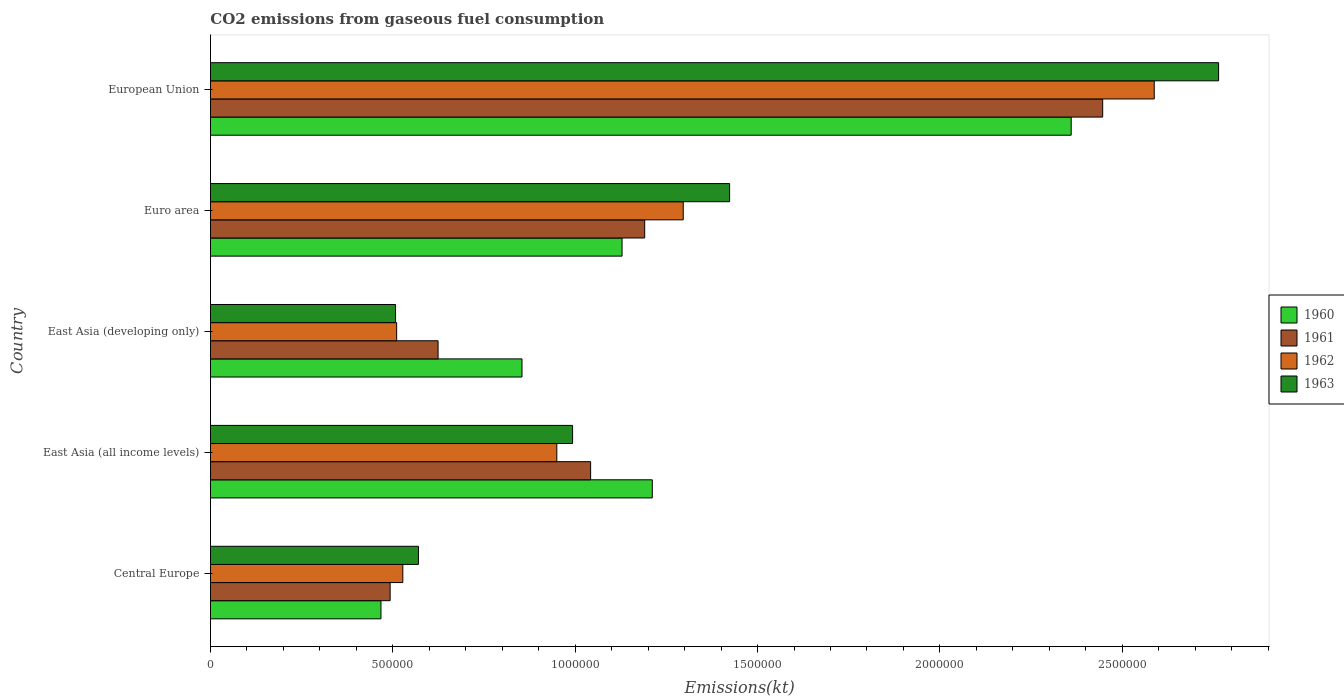Are the number of bars on each tick of the Y-axis equal?
Offer a very short reply. Yes. How many bars are there on the 1st tick from the top?
Offer a very short reply. 4. What is the label of the 1st group of bars from the top?
Offer a very short reply. European Union. What is the amount of CO2 emitted in 1961 in East Asia (developing only)?
Your answer should be very brief. 6.24e+05. Across all countries, what is the maximum amount of CO2 emitted in 1961?
Give a very brief answer. 2.45e+06. Across all countries, what is the minimum amount of CO2 emitted in 1961?
Your response must be concise. 4.93e+05. In which country was the amount of CO2 emitted in 1960 maximum?
Your response must be concise. European Union. In which country was the amount of CO2 emitted in 1961 minimum?
Provide a short and direct response. Central Europe. What is the total amount of CO2 emitted in 1960 in the graph?
Make the answer very short. 6.02e+06. What is the difference between the amount of CO2 emitted in 1960 in East Asia (developing only) and that in Euro area?
Provide a short and direct response. -2.74e+05. What is the difference between the amount of CO2 emitted in 1962 in Central Europe and the amount of CO2 emitted in 1963 in European Union?
Provide a short and direct response. -2.24e+06. What is the average amount of CO2 emitted in 1961 per country?
Offer a terse response. 1.16e+06. What is the difference between the amount of CO2 emitted in 1963 and amount of CO2 emitted in 1962 in European Union?
Give a very brief answer. 1.76e+05. In how many countries, is the amount of CO2 emitted in 1961 greater than 200000 kt?
Ensure brevity in your answer.  5. What is the ratio of the amount of CO2 emitted in 1963 in East Asia (all income levels) to that in East Asia (developing only)?
Provide a short and direct response. 1.96. Is the amount of CO2 emitted in 1962 in Central Europe less than that in European Union?
Provide a succinct answer. Yes. What is the difference between the highest and the second highest amount of CO2 emitted in 1961?
Your answer should be compact. 1.26e+06. What is the difference between the highest and the lowest amount of CO2 emitted in 1961?
Ensure brevity in your answer.  1.95e+06. What does the 2nd bar from the bottom in East Asia (developing only) represents?
Provide a short and direct response. 1961. Is it the case that in every country, the sum of the amount of CO2 emitted in 1962 and amount of CO2 emitted in 1963 is greater than the amount of CO2 emitted in 1961?
Offer a terse response. Yes. How many bars are there?
Ensure brevity in your answer.  20. Does the graph contain any zero values?
Your response must be concise. No. Does the graph contain grids?
Provide a succinct answer. No. How many legend labels are there?
Provide a short and direct response. 4. What is the title of the graph?
Offer a terse response. CO2 emissions from gaseous fuel consumption. Does "1969" appear as one of the legend labels in the graph?
Keep it short and to the point. No. What is the label or title of the X-axis?
Give a very brief answer. Emissions(kt). What is the label or title of the Y-axis?
Offer a very short reply. Country. What is the Emissions(kt) of 1960 in Central Europe?
Make the answer very short. 4.67e+05. What is the Emissions(kt) of 1961 in Central Europe?
Your response must be concise. 4.93e+05. What is the Emissions(kt) in 1962 in Central Europe?
Offer a very short reply. 5.27e+05. What is the Emissions(kt) of 1963 in Central Europe?
Provide a succinct answer. 5.70e+05. What is the Emissions(kt) in 1960 in East Asia (all income levels)?
Your answer should be compact. 1.21e+06. What is the Emissions(kt) in 1961 in East Asia (all income levels)?
Ensure brevity in your answer.  1.04e+06. What is the Emissions(kt) in 1962 in East Asia (all income levels)?
Your answer should be very brief. 9.50e+05. What is the Emissions(kt) of 1963 in East Asia (all income levels)?
Provide a short and direct response. 9.93e+05. What is the Emissions(kt) of 1960 in East Asia (developing only)?
Ensure brevity in your answer.  8.54e+05. What is the Emissions(kt) of 1961 in East Asia (developing only)?
Offer a very short reply. 6.24e+05. What is the Emissions(kt) in 1962 in East Asia (developing only)?
Make the answer very short. 5.10e+05. What is the Emissions(kt) in 1963 in East Asia (developing only)?
Make the answer very short. 5.07e+05. What is the Emissions(kt) in 1960 in Euro area?
Provide a succinct answer. 1.13e+06. What is the Emissions(kt) in 1961 in Euro area?
Keep it short and to the point. 1.19e+06. What is the Emissions(kt) in 1962 in Euro area?
Make the answer very short. 1.30e+06. What is the Emissions(kt) in 1963 in Euro area?
Your answer should be compact. 1.42e+06. What is the Emissions(kt) of 1960 in European Union?
Offer a terse response. 2.36e+06. What is the Emissions(kt) of 1961 in European Union?
Give a very brief answer. 2.45e+06. What is the Emissions(kt) in 1962 in European Union?
Ensure brevity in your answer.  2.59e+06. What is the Emissions(kt) in 1963 in European Union?
Your answer should be very brief. 2.76e+06. Across all countries, what is the maximum Emissions(kt) of 1960?
Give a very brief answer. 2.36e+06. Across all countries, what is the maximum Emissions(kt) in 1961?
Ensure brevity in your answer.  2.45e+06. Across all countries, what is the maximum Emissions(kt) in 1962?
Offer a very short reply. 2.59e+06. Across all countries, what is the maximum Emissions(kt) in 1963?
Your answer should be very brief. 2.76e+06. Across all countries, what is the minimum Emissions(kt) in 1960?
Your answer should be compact. 4.67e+05. Across all countries, what is the minimum Emissions(kt) of 1961?
Give a very brief answer. 4.93e+05. Across all countries, what is the minimum Emissions(kt) of 1962?
Give a very brief answer. 5.10e+05. Across all countries, what is the minimum Emissions(kt) of 1963?
Make the answer very short. 5.07e+05. What is the total Emissions(kt) of 1960 in the graph?
Keep it short and to the point. 6.02e+06. What is the total Emissions(kt) in 1961 in the graph?
Keep it short and to the point. 5.80e+06. What is the total Emissions(kt) in 1962 in the graph?
Offer a terse response. 5.87e+06. What is the total Emissions(kt) of 1963 in the graph?
Offer a terse response. 6.26e+06. What is the difference between the Emissions(kt) of 1960 in Central Europe and that in East Asia (all income levels)?
Offer a terse response. -7.44e+05. What is the difference between the Emissions(kt) in 1961 in Central Europe and that in East Asia (all income levels)?
Provide a short and direct response. -5.50e+05. What is the difference between the Emissions(kt) of 1962 in Central Europe and that in East Asia (all income levels)?
Your answer should be compact. -4.22e+05. What is the difference between the Emissions(kt) of 1963 in Central Europe and that in East Asia (all income levels)?
Make the answer very short. -4.23e+05. What is the difference between the Emissions(kt) in 1960 in Central Europe and that in East Asia (developing only)?
Give a very brief answer. -3.87e+05. What is the difference between the Emissions(kt) in 1961 in Central Europe and that in East Asia (developing only)?
Provide a short and direct response. -1.31e+05. What is the difference between the Emissions(kt) of 1962 in Central Europe and that in East Asia (developing only)?
Provide a short and direct response. 1.69e+04. What is the difference between the Emissions(kt) of 1963 in Central Europe and that in East Asia (developing only)?
Ensure brevity in your answer.  6.27e+04. What is the difference between the Emissions(kt) in 1960 in Central Europe and that in Euro area?
Offer a terse response. -6.61e+05. What is the difference between the Emissions(kt) in 1961 in Central Europe and that in Euro area?
Provide a short and direct response. -6.98e+05. What is the difference between the Emissions(kt) in 1962 in Central Europe and that in Euro area?
Offer a terse response. -7.69e+05. What is the difference between the Emissions(kt) in 1963 in Central Europe and that in Euro area?
Your answer should be compact. -8.53e+05. What is the difference between the Emissions(kt) in 1960 in Central Europe and that in European Union?
Offer a very short reply. -1.89e+06. What is the difference between the Emissions(kt) of 1961 in Central Europe and that in European Union?
Give a very brief answer. -1.95e+06. What is the difference between the Emissions(kt) of 1962 in Central Europe and that in European Union?
Offer a very short reply. -2.06e+06. What is the difference between the Emissions(kt) of 1963 in Central Europe and that in European Union?
Offer a terse response. -2.19e+06. What is the difference between the Emissions(kt) in 1960 in East Asia (all income levels) and that in East Asia (developing only)?
Offer a very short reply. 3.57e+05. What is the difference between the Emissions(kt) in 1961 in East Asia (all income levels) and that in East Asia (developing only)?
Your answer should be very brief. 4.18e+05. What is the difference between the Emissions(kt) in 1962 in East Asia (all income levels) and that in East Asia (developing only)?
Your answer should be compact. 4.39e+05. What is the difference between the Emissions(kt) of 1963 in East Asia (all income levels) and that in East Asia (developing only)?
Offer a terse response. 4.85e+05. What is the difference between the Emissions(kt) in 1960 in East Asia (all income levels) and that in Euro area?
Ensure brevity in your answer.  8.29e+04. What is the difference between the Emissions(kt) of 1961 in East Asia (all income levels) and that in Euro area?
Ensure brevity in your answer.  -1.48e+05. What is the difference between the Emissions(kt) of 1962 in East Asia (all income levels) and that in Euro area?
Provide a short and direct response. -3.47e+05. What is the difference between the Emissions(kt) in 1963 in East Asia (all income levels) and that in Euro area?
Your answer should be very brief. -4.30e+05. What is the difference between the Emissions(kt) of 1960 in East Asia (all income levels) and that in European Union?
Provide a succinct answer. -1.15e+06. What is the difference between the Emissions(kt) in 1961 in East Asia (all income levels) and that in European Union?
Ensure brevity in your answer.  -1.40e+06. What is the difference between the Emissions(kt) of 1962 in East Asia (all income levels) and that in European Union?
Your answer should be compact. -1.64e+06. What is the difference between the Emissions(kt) in 1963 in East Asia (all income levels) and that in European Union?
Ensure brevity in your answer.  -1.77e+06. What is the difference between the Emissions(kt) of 1960 in East Asia (developing only) and that in Euro area?
Your answer should be compact. -2.74e+05. What is the difference between the Emissions(kt) in 1961 in East Asia (developing only) and that in Euro area?
Make the answer very short. -5.66e+05. What is the difference between the Emissions(kt) of 1962 in East Asia (developing only) and that in Euro area?
Provide a succinct answer. -7.86e+05. What is the difference between the Emissions(kt) of 1963 in East Asia (developing only) and that in Euro area?
Offer a very short reply. -9.16e+05. What is the difference between the Emissions(kt) of 1960 in East Asia (developing only) and that in European Union?
Provide a short and direct response. -1.51e+06. What is the difference between the Emissions(kt) in 1961 in East Asia (developing only) and that in European Union?
Provide a short and direct response. -1.82e+06. What is the difference between the Emissions(kt) in 1962 in East Asia (developing only) and that in European Union?
Your response must be concise. -2.08e+06. What is the difference between the Emissions(kt) in 1963 in East Asia (developing only) and that in European Union?
Your answer should be compact. -2.26e+06. What is the difference between the Emissions(kt) of 1960 in Euro area and that in European Union?
Your response must be concise. -1.23e+06. What is the difference between the Emissions(kt) in 1961 in Euro area and that in European Union?
Ensure brevity in your answer.  -1.26e+06. What is the difference between the Emissions(kt) in 1962 in Euro area and that in European Union?
Keep it short and to the point. -1.29e+06. What is the difference between the Emissions(kt) of 1963 in Euro area and that in European Union?
Provide a succinct answer. -1.34e+06. What is the difference between the Emissions(kt) of 1960 in Central Europe and the Emissions(kt) of 1961 in East Asia (all income levels)?
Your answer should be very brief. -5.75e+05. What is the difference between the Emissions(kt) of 1960 in Central Europe and the Emissions(kt) of 1962 in East Asia (all income levels)?
Provide a short and direct response. -4.82e+05. What is the difference between the Emissions(kt) of 1960 in Central Europe and the Emissions(kt) of 1963 in East Asia (all income levels)?
Your answer should be compact. -5.25e+05. What is the difference between the Emissions(kt) of 1961 in Central Europe and the Emissions(kt) of 1962 in East Asia (all income levels)?
Your answer should be very brief. -4.57e+05. What is the difference between the Emissions(kt) in 1961 in Central Europe and the Emissions(kt) in 1963 in East Asia (all income levels)?
Give a very brief answer. -5.00e+05. What is the difference between the Emissions(kt) of 1962 in Central Europe and the Emissions(kt) of 1963 in East Asia (all income levels)?
Offer a very short reply. -4.66e+05. What is the difference between the Emissions(kt) in 1960 in Central Europe and the Emissions(kt) in 1961 in East Asia (developing only)?
Your answer should be compact. -1.57e+05. What is the difference between the Emissions(kt) in 1960 in Central Europe and the Emissions(kt) in 1962 in East Asia (developing only)?
Offer a very short reply. -4.30e+04. What is the difference between the Emissions(kt) of 1960 in Central Europe and the Emissions(kt) of 1963 in East Asia (developing only)?
Offer a terse response. -4.00e+04. What is the difference between the Emissions(kt) of 1961 in Central Europe and the Emissions(kt) of 1962 in East Asia (developing only)?
Offer a very short reply. -1.78e+04. What is the difference between the Emissions(kt) of 1961 in Central Europe and the Emissions(kt) of 1963 in East Asia (developing only)?
Give a very brief answer. -1.49e+04. What is the difference between the Emissions(kt) of 1962 in Central Europe and the Emissions(kt) of 1963 in East Asia (developing only)?
Provide a short and direct response. 1.98e+04. What is the difference between the Emissions(kt) in 1960 in Central Europe and the Emissions(kt) in 1961 in Euro area?
Your answer should be very brief. -7.23e+05. What is the difference between the Emissions(kt) of 1960 in Central Europe and the Emissions(kt) of 1962 in Euro area?
Keep it short and to the point. -8.29e+05. What is the difference between the Emissions(kt) in 1960 in Central Europe and the Emissions(kt) in 1963 in Euro area?
Offer a terse response. -9.56e+05. What is the difference between the Emissions(kt) in 1961 in Central Europe and the Emissions(kt) in 1962 in Euro area?
Offer a terse response. -8.04e+05. What is the difference between the Emissions(kt) of 1961 in Central Europe and the Emissions(kt) of 1963 in Euro area?
Ensure brevity in your answer.  -9.31e+05. What is the difference between the Emissions(kt) in 1962 in Central Europe and the Emissions(kt) in 1963 in Euro area?
Ensure brevity in your answer.  -8.96e+05. What is the difference between the Emissions(kt) in 1960 in Central Europe and the Emissions(kt) in 1961 in European Union?
Give a very brief answer. -1.98e+06. What is the difference between the Emissions(kt) in 1960 in Central Europe and the Emissions(kt) in 1962 in European Union?
Provide a short and direct response. -2.12e+06. What is the difference between the Emissions(kt) of 1960 in Central Europe and the Emissions(kt) of 1963 in European Union?
Provide a short and direct response. -2.30e+06. What is the difference between the Emissions(kt) of 1961 in Central Europe and the Emissions(kt) of 1962 in European Union?
Offer a very short reply. -2.09e+06. What is the difference between the Emissions(kt) of 1961 in Central Europe and the Emissions(kt) of 1963 in European Union?
Offer a very short reply. -2.27e+06. What is the difference between the Emissions(kt) of 1962 in Central Europe and the Emissions(kt) of 1963 in European Union?
Your answer should be very brief. -2.24e+06. What is the difference between the Emissions(kt) in 1960 in East Asia (all income levels) and the Emissions(kt) in 1961 in East Asia (developing only)?
Offer a very short reply. 5.87e+05. What is the difference between the Emissions(kt) in 1960 in East Asia (all income levels) and the Emissions(kt) in 1962 in East Asia (developing only)?
Give a very brief answer. 7.01e+05. What is the difference between the Emissions(kt) of 1960 in East Asia (all income levels) and the Emissions(kt) of 1963 in East Asia (developing only)?
Your answer should be compact. 7.04e+05. What is the difference between the Emissions(kt) in 1961 in East Asia (all income levels) and the Emissions(kt) in 1962 in East Asia (developing only)?
Your response must be concise. 5.32e+05. What is the difference between the Emissions(kt) of 1961 in East Asia (all income levels) and the Emissions(kt) of 1963 in East Asia (developing only)?
Your answer should be very brief. 5.35e+05. What is the difference between the Emissions(kt) in 1962 in East Asia (all income levels) and the Emissions(kt) in 1963 in East Asia (developing only)?
Make the answer very short. 4.42e+05. What is the difference between the Emissions(kt) of 1960 in East Asia (all income levels) and the Emissions(kt) of 1961 in Euro area?
Your answer should be compact. 2.09e+04. What is the difference between the Emissions(kt) of 1960 in East Asia (all income levels) and the Emissions(kt) of 1962 in Euro area?
Offer a very short reply. -8.48e+04. What is the difference between the Emissions(kt) in 1960 in East Asia (all income levels) and the Emissions(kt) in 1963 in Euro area?
Your answer should be compact. -2.12e+05. What is the difference between the Emissions(kt) of 1961 in East Asia (all income levels) and the Emissions(kt) of 1962 in Euro area?
Your answer should be compact. -2.54e+05. What is the difference between the Emissions(kt) in 1961 in East Asia (all income levels) and the Emissions(kt) in 1963 in Euro area?
Give a very brief answer. -3.81e+05. What is the difference between the Emissions(kt) in 1962 in East Asia (all income levels) and the Emissions(kt) in 1963 in Euro area?
Your answer should be compact. -4.74e+05. What is the difference between the Emissions(kt) in 1960 in East Asia (all income levels) and the Emissions(kt) in 1961 in European Union?
Offer a very short reply. -1.23e+06. What is the difference between the Emissions(kt) in 1960 in East Asia (all income levels) and the Emissions(kt) in 1962 in European Union?
Your answer should be very brief. -1.38e+06. What is the difference between the Emissions(kt) of 1960 in East Asia (all income levels) and the Emissions(kt) of 1963 in European Union?
Offer a very short reply. -1.55e+06. What is the difference between the Emissions(kt) of 1961 in East Asia (all income levels) and the Emissions(kt) of 1962 in European Union?
Make the answer very short. -1.55e+06. What is the difference between the Emissions(kt) in 1961 in East Asia (all income levels) and the Emissions(kt) in 1963 in European Union?
Ensure brevity in your answer.  -1.72e+06. What is the difference between the Emissions(kt) in 1962 in East Asia (all income levels) and the Emissions(kt) in 1963 in European Union?
Your answer should be compact. -1.81e+06. What is the difference between the Emissions(kt) of 1960 in East Asia (developing only) and the Emissions(kt) of 1961 in Euro area?
Offer a terse response. -3.36e+05. What is the difference between the Emissions(kt) of 1960 in East Asia (developing only) and the Emissions(kt) of 1962 in Euro area?
Provide a short and direct response. -4.42e+05. What is the difference between the Emissions(kt) in 1960 in East Asia (developing only) and the Emissions(kt) in 1963 in Euro area?
Provide a succinct answer. -5.69e+05. What is the difference between the Emissions(kt) in 1961 in East Asia (developing only) and the Emissions(kt) in 1962 in Euro area?
Your response must be concise. -6.72e+05. What is the difference between the Emissions(kt) of 1961 in East Asia (developing only) and the Emissions(kt) of 1963 in Euro area?
Your response must be concise. -7.99e+05. What is the difference between the Emissions(kt) of 1962 in East Asia (developing only) and the Emissions(kt) of 1963 in Euro area?
Offer a very short reply. -9.13e+05. What is the difference between the Emissions(kt) in 1960 in East Asia (developing only) and the Emissions(kt) in 1961 in European Union?
Keep it short and to the point. -1.59e+06. What is the difference between the Emissions(kt) of 1960 in East Asia (developing only) and the Emissions(kt) of 1962 in European Union?
Ensure brevity in your answer.  -1.73e+06. What is the difference between the Emissions(kt) of 1960 in East Asia (developing only) and the Emissions(kt) of 1963 in European Union?
Provide a succinct answer. -1.91e+06. What is the difference between the Emissions(kt) of 1961 in East Asia (developing only) and the Emissions(kt) of 1962 in European Union?
Ensure brevity in your answer.  -1.96e+06. What is the difference between the Emissions(kt) in 1961 in East Asia (developing only) and the Emissions(kt) in 1963 in European Union?
Offer a terse response. -2.14e+06. What is the difference between the Emissions(kt) of 1962 in East Asia (developing only) and the Emissions(kt) of 1963 in European Union?
Make the answer very short. -2.25e+06. What is the difference between the Emissions(kt) in 1960 in Euro area and the Emissions(kt) in 1961 in European Union?
Provide a short and direct response. -1.32e+06. What is the difference between the Emissions(kt) of 1960 in Euro area and the Emissions(kt) of 1962 in European Union?
Offer a terse response. -1.46e+06. What is the difference between the Emissions(kt) in 1960 in Euro area and the Emissions(kt) in 1963 in European Union?
Keep it short and to the point. -1.64e+06. What is the difference between the Emissions(kt) in 1961 in Euro area and the Emissions(kt) in 1962 in European Union?
Keep it short and to the point. -1.40e+06. What is the difference between the Emissions(kt) in 1961 in Euro area and the Emissions(kt) in 1963 in European Union?
Your response must be concise. -1.57e+06. What is the difference between the Emissions(kt) in 1962 in Euro area and the Emissions(kt) in 1963 in European Union?
Make the answer very short. -1.47e+06. What is the average Emissions(kt) in 1960 per country?
Provide a succinct answer. 1.20e+06. What is the average Emissions(kt) in 1961 per country?
Make the answer very short. 1.16e+06. What is the average Emissions(kt) of 1962 per country?
Your answer should be compact. 1.17e+06. What is the average Emissions(kt) in 1963 per country?
Provide a succinct answer. 1.25e+06. What is the difference between the Emissions(kt) in 1960 and Emissions(kt) in 1961 in Central Europe?
Make the answer very short. -2.52e+04. What is the difference between the Emissions(kt) of 1960 and Emissions(kt) of 1962 in Central Europe?
Offer a very short reply. -5.99e+04. What is the difference between the Emissions(kt) of 1960 and Emissions(kt) of 1963 in Central Europe?
Keep it short and to the point. -1.03e+05. What is the difference between the Emissions(kt) of 1961 and Emissions(kt) of 1962 in Central Europe?
Provide a succinct answer. -3.47e+04. What is the difference between the Emissions(kt) in 1961 and Emissions(kt) in 1963 in Central Europe?
Provide a short and direct response. -7.76e+04. What is the difference between the Emissions(kt) in 1962 and Emissions(kt) in 1963 in Central Europe?
Give a very brief answer. -4.29e+04. What is the difference between the Emissions(kt) in 1960 and Emissions(kt) in 1961 in East Asia (all income levels)?
Make the answer very short. 1.69e+05. What is the difference between the Emissions(kt) in 1960 and Emissions(kt) in 1962 in East Asia (all income levels)?
Keep it short and to the point. 2.62e+05. What is the difference between the Emissions(kt) in 1960 and Emissions(kt) in 1963 in East Asia (all income levels)?
Provide a succinct answer. 2.19e+05. What is the difference between the Emissions(kt) in 1961 and Emissions(kt) in 1962 in East Asia (all income levels)?
Make the answer very short. 9.27e+04. What is the difference between the Emissions(kt) of 1961 and Emissions(kt) of 1963 in East Asia (all income levels)?
Give a very brief answer. 4.94e+04. What is the difference between the Emissions(kt) of 1962 and Emissions(kt) of 1963 in East Asia (all income levels)?
Keep it short and to the point. -4.33e+04. What is the difference between the Emissions(kt) in 1960 and Emissions(kt) in 1961 in East Asia (developing only)?
Offer a terse response. 2.30e+05. What is the difference between the Emissions(kt) in 1960 and Emissions(kt) in 1962 in East Asia (developing only)?
Offer a terse response. 3.44e+05. What is the difference between the Emissions(kt) in 1960 and Emissions(kt) in 1963 in East Asia (developing only)?
Your response must be concise. 3.47e+05. What is the difference between the Emissions(kt) of 1961 and Emissions(kt) of 1962 in East Asia (developing only)?
Ensure brevity in your answer.  1.14e+05. What is the difference between the Emissions(kt) in 1961 and Emissions(kt) in 1963 in East Asia (developing only)?
Your answer should be very brief. 1.17e+05. What is the difference between the Emissions(kt) in 1962 and Emissions(kt) in 1963 in East Asia (developing only)?
Offer a terse response. 2970.98. What is the difference between the Emissions(kt) in 1960 and Emissions(kt) in 1961 in Euro area?
Your answer should be very brief. -6.20e+04. What is the difference between the Emissions(kt) of 1960 and Emissions(kt) of 1962 in Euro area?
Offer a terse response. -1.68e+05. What is the difference between the Emissions(kt) in 1960 and Emissions(kt) in 1963 in Euro area?
Provide a succinct answer. -2.95e+05. What is the difference between the Emissions(kt) in 1961 and Emissions(kt) in 1962 in Euro area?
Your answer should be compact. -1.06e+05. What is the difference between the Emissions(kt) of 1961 and Emissions(kt) of 1963 in Euro area?
Keep it short and to the point. -2.33e+05. What is the difference between the Emissions(kt) in 1962 and Emissions(kt) in 1963 in Euro area?
Ensure brevity in your answer.  -1.27e+05. What is the difference between the Emissions(kt) in 1960 and Emissions(kt) in 1961 in European Union?
Your response must be concise. -8.64e+04. What is the difference between the Emissions(kt) of 1960 and Emissions(kt) of 1962 in European Union?
Provide a succinct answer. -2.28e+05. What is the difference between the Emissions(kt) in 1960 and Emissions(kt) in 1963 in European Union?
Give a very brief answer. -4.04e+05. What is the difference between the Emissions(kt) of 1961 and Emissions(kt) of 1962 in European Union?
Keep it short and to the point. -1.41e+05. What is the difference between the Emissions(kt) in 1961 and Emissions(kt) in 1963 in European Union?
Offer a very short reply. -3.18e+05. What is the difference between the Emissions(kt) in 1962 and Emissions(kt) in 1963 in European Union?
Your answer should be very brief. -1.76e+05. What is the ratio of the Emissions(kt) in 1960 in Central Europe to that in East Asia (all income levels)?
Offer a terse response. 0.39. What is the ratio of the Emissions(kt) of 1961 in Central Europe to that in East Asia (all income levels)?
Your answer should be compact. 0.47. What is the ratio of the Emissions(kt) of 1962 in Central Europe to that in East Asia (all income levels)?
Your response must be concise. 0.56. What is the ratio of the Emissions(kt) of 1963 in Central Europe to that in East Asia (all income levels)?
Offer a terse response. 0.57. What is the ratio of the Emissions(kt) in 1960 in Central Europe to that in East Asia (developing only)?
Provide a short and direct response. 0.55. What is the ratio of the Emissions(kt) in 1961 in Central Europe to that in East Asia (developing only)?
Offer a very short reply. 0.79. What is the ratio of the Emissions(kt) of 1962 in Central Europe to that in East Asia (developing only)?
Make the answer very short. 1.03. What is the ratio of the Emissions(kt) of 1963 in Central Europe to that in East Asia (developing only)?
Make the answer very short. 1.12. What is the ratio of the Emissions(kt) of 1960 in Central Europe to that in Euro area?
Your response must be concise. 0.41. What is the ratio of the Emissions(kt) of 1961 in Central Europe to that in Euro area?
Your answer should be very brief. 0.41. What is the ratio of the Emissions(kt) in 1962 in Central Europe to that in Euro area?
Provide a short and direct response. 0.41. What is the ratio of the Emissions(kt) in 1963 in Central Europe to that in Euro area?
Ensure brevity in your answer.  0.4. What is the ratio of the Emissions(kt) of 1960 in Central Europe to that in European Union?
Give a very brief answer. 0.2. What is the ratio of the Emissions(kt) of 1961 in Central Europe to that in European Union?
Give a very brief answer. 0.2. What is the ratio of the Emissions(kt) in 1962 in Central Europe to that in European Union?
Your answer should be very brief. 0.2. What is the ratio of the Emissions(kt) in 1963 in Central Europe to that in European Union?
Your answer should be very brief. 0.21. What is the ratio of the Emissions(kt) of 1960 in East Asia (all income levels) to that in East Asia (developing only)?
Offer a terse response. 1.42. What is the ratio of the Emissions(kt) in 1961 in East Asia (all income levels) to that in East Asia (developing only)?
Your answer should be very brief. 1.67. What is the ratio of the Emissions(kt) of 1962 in East Asia (all income levels) to that in East Asia (developing only)?
Your answer should be very brief. 1.86. What is the ratio of the Emissions(kt) in 1963 in East Asia (all income levels) to that in East Asia (developing only)?
Make the answer very short. 1.96. What is the ratio of the Emissions(kt) of 1960 in East Asia (all income levels) to that in Euro area?
Your answer should be very brief. 1.07. What is the ratio of the Emissions(kt) in 1961 in East Asia (all income levels) to that in Euro area?
Offer a very short reply. 0.88. What is the ratio of the Emissions(kt) of 1962 in East Asia (all income levels) to that in Euro area?
Your response must be concise. 0.73. What is the ratio of the Emissions(kt) in 1963 in East Asia (all income levels) to that in Euro area?
Provide a succinct answer. 0.7. What is the ratio of the Emissions(kt) of 1960 in East Asia (all income levels) to that in European Union?
Provide a short and direct response. 0.51. What is the ratio of the Emissions(kt) in 1961 in East Asia (all income levels) to that in European Union?
Make the answer very short. 0.43. What is the ratio of the Emissions(kt) in 1962 in East Asia (all income levels) to that in European Union?
Offer a terse response. 0.37. What is the ratio of the Emissions(kt) in 1963 in East Asia (all income levels) to that in European Union?
Make the answer very short. 0.36. What is the ratio of the Emissions(kt) of 1960 in East Asia (developing only) to that in Euro area?
Your response must be concise. 0.76. What is the ratio of the Emissions(kt) of 1961 in East Asia (developing only) to that in Euro area?
Offer a very short reply. 0.52. What is the ratio of the Emissions(kt) in 1962 in East Asia (developing only) to that in Euro area?
Provide a succinct answer. 0.39. What is the ratio of the Emissions(kt) in 1963 in East Asia (developing only) to that in Euro area?
Your response must be concise. 0.36. What is the ratio of the Emissions(kt) in 1960 in East Asia (developing only) to that in European Union?
Offer a terse response. 0.36. What is the ratio of the Emissions(kt) in 1961 in East Asia (developing only) to that in European Union?
Provide a short and direct response. 0.26. What is the ratio of the Emissions(kt) of 1962 in East Asia (developing only) to that in European Union?
Ensure brevity in your answer.  0.2. What is the ratio of the Emissions(kt) of 1963 in East Asia (developing only) to that in European Union?
Make the answer very short. 0.18. What is the ratio of the Emissions(kt) in 1960 in Euro area to that in European Union?
Provide a short and direct response. 0.48. What is the ratio of the Emissions(kt) of 1961 in Euro area to that in European Union?
Keep it short and to the point. 0.49. What is the ratio of the Emissions(kt) of 1962 in Euro area to that in European Union?
Provide a succinct answer. 0.5. What is the ratio of the Emissions(kt) in 1963 in Euro area to that in European Union?
Your answer should be very brief. 0.52. What is the difference between the highest and the second highest Emissions(kt) of 1960?
Provide a short and direct response. 1.15e+06. What is the difference between the highest and the second highest Emissions(kt) of 1961?
Provide a short and direct response. 1.26e+06. What is the difference between the highest and the second highest Emissions(kt) in 1962?
Provide a succinct answer. 1.29e+06. What is the difference between the highest and the second highest Emissions(kt) of 1963?
Give a very brief answer. 1.34e+06. What is the difference between the highest and the lowest Emissions(kt) in 1960?
Your response must be concise. 1.89e+06. What is the difference between the highest and the lowest Emissions(kt) of 1961?
Keep it short and to the point. 1.95e+06. What is the difference between the highest and the lowest Emissions(kt) of 1962?
Provide a succinct answer. 2.08e+06. What is the difference between the highest and the lowest Emissions(kt) of 1963?
Make the answer very short. 2.26e+06. 